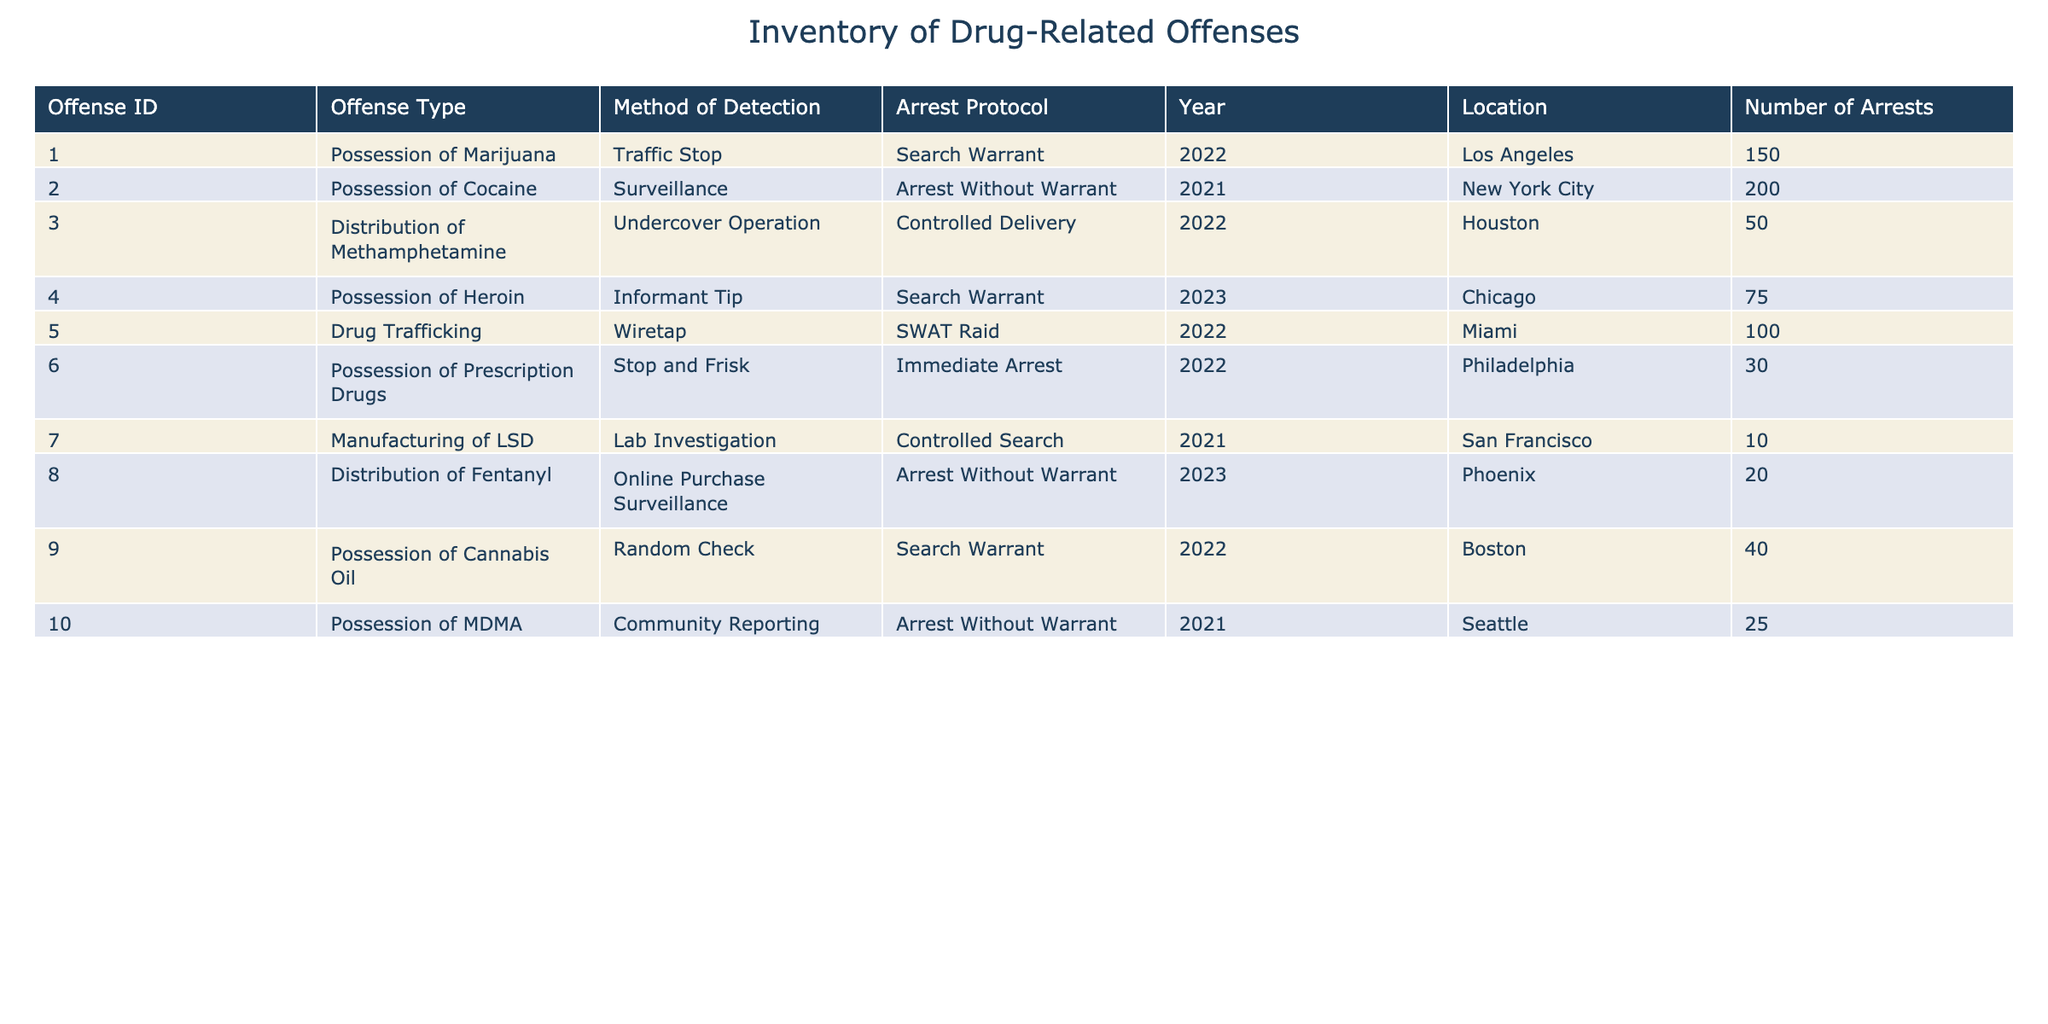What is the total number of arrests recorded in 2022? In the table, we need to look for all entries with the year 2022. The relevant rows are for offenses related to possession of marijuana, distribution of methamphetamine, drug trafficking, possession of prescription drugs, and possession of cannabis oil. Summing these arrests gives us: 150 (marijuana) + 50 (methamphetamine) + 100 (drug trafficking) + 30 (prescription drugs) + 40 (cannabis oil) = 370.
Answer: 370 How many different methods of detection are used in the table? To determine the number of different methods of detection, we need to look through the "Method of Detection" column and count the unique methods listed. The methods are traffic stop, surveillance, undercover operation, informant tip, wiretap, stop and frisk, lab investigation, online purchase surveillance, and random check. There are 9 unique methods in total.
Answer: 9 What is the average number of arrests for offenses categorized under "Arrest Without Warrant"? First, identify the entries with the "Arrest Without Warrant" protocol. The total arrests in this category are: 200 (cocaine) + 20 (fentanyl) + 25 (MDMA) = 245. There are 3 entries in this category. Therefore, the average number of arrests is 245 divided by 3, which equals approximately 81.67.
Answer: 81.67 Is the value for number of arrests in the "Possession of Heroin" case greater than the arrests in "Distribution of Methamphetamine"? We compare the number of arrests from both cases. The "Possession of Heroin" has 75 arrests, while "Distribution of Methamphetamine" has 50 arrests. Since 75 is greater than 50, this statement is true.
Answer: Yes Which location has the highest number of arrests for drug-related offenses? By examining the table's "Location" and "Number of Arrests" columns, we identify the arrests for each location: Los Angeles (150), New York City (200), Houston (50), Chicago (75), Miami (100), Philadelphia (30), San Francisco (10), Phoenix (20), and Boston (40). The highest figure is 200 arrests in New York City.
Answer: New York City 